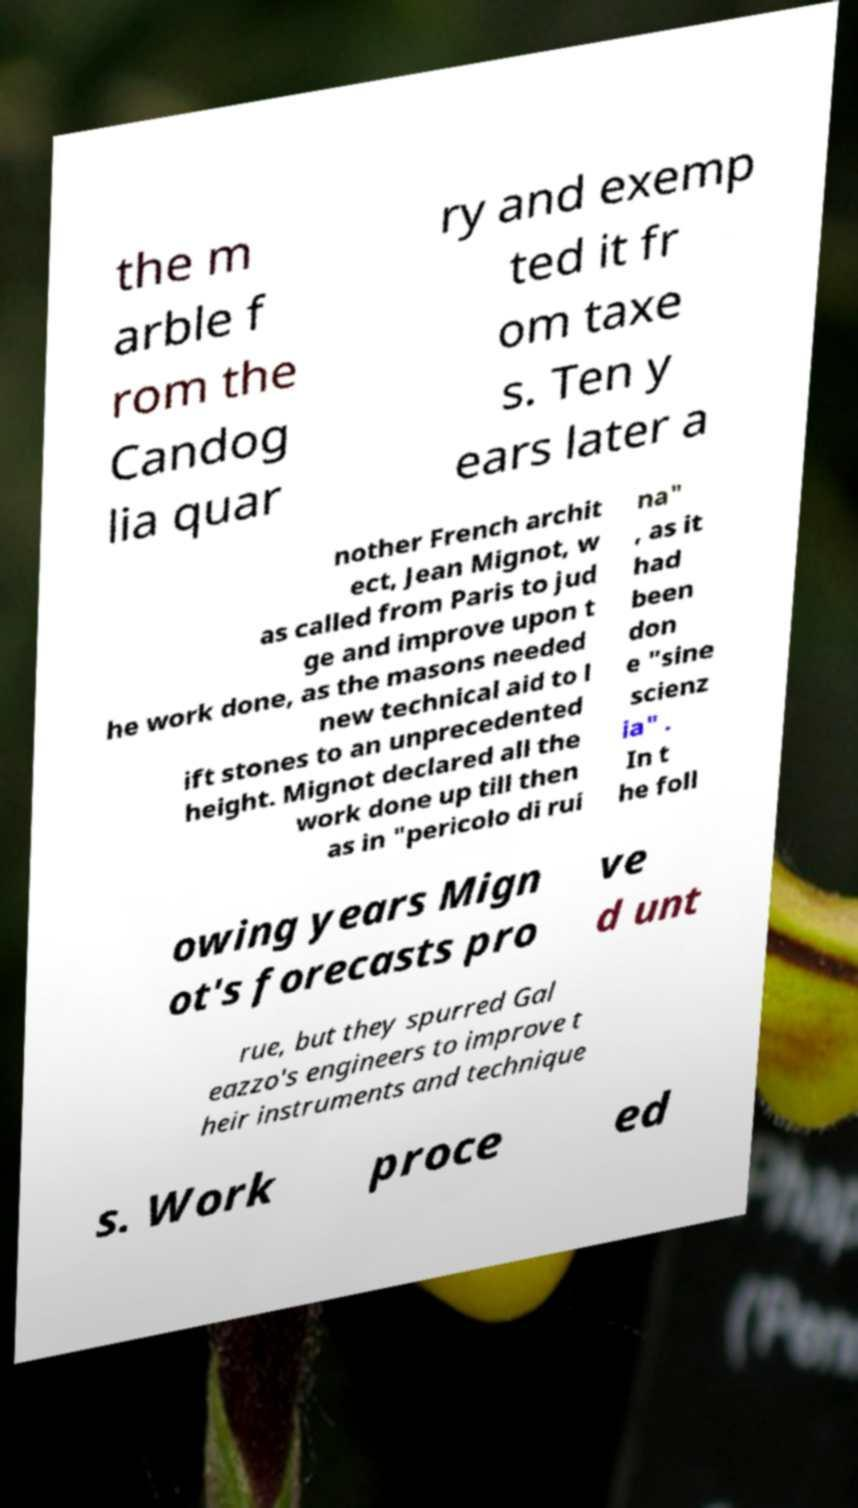For documentation purposes, I need the text within this image transcribed. Could you provide that? the m arble f rom the Candog lia quar ry and exemp ted it fr om taxe s. Ten y ears later a nother French archit ect, Jean Mignot, w as called from Paris to jud ge and improve upon t he work done, as the masons needed new technical aid to l ift stones to an unprecedented height. Mignot declared all the work done up till then as in "pericolo di rui na" , as it had been don e "sine scienz ia" . In t he foll owing years Mign ot's forecasts pro ve d unt rue, but they spurred Gal eazzo's engineers to improve t heir instruments and technique s. Work proce ed 